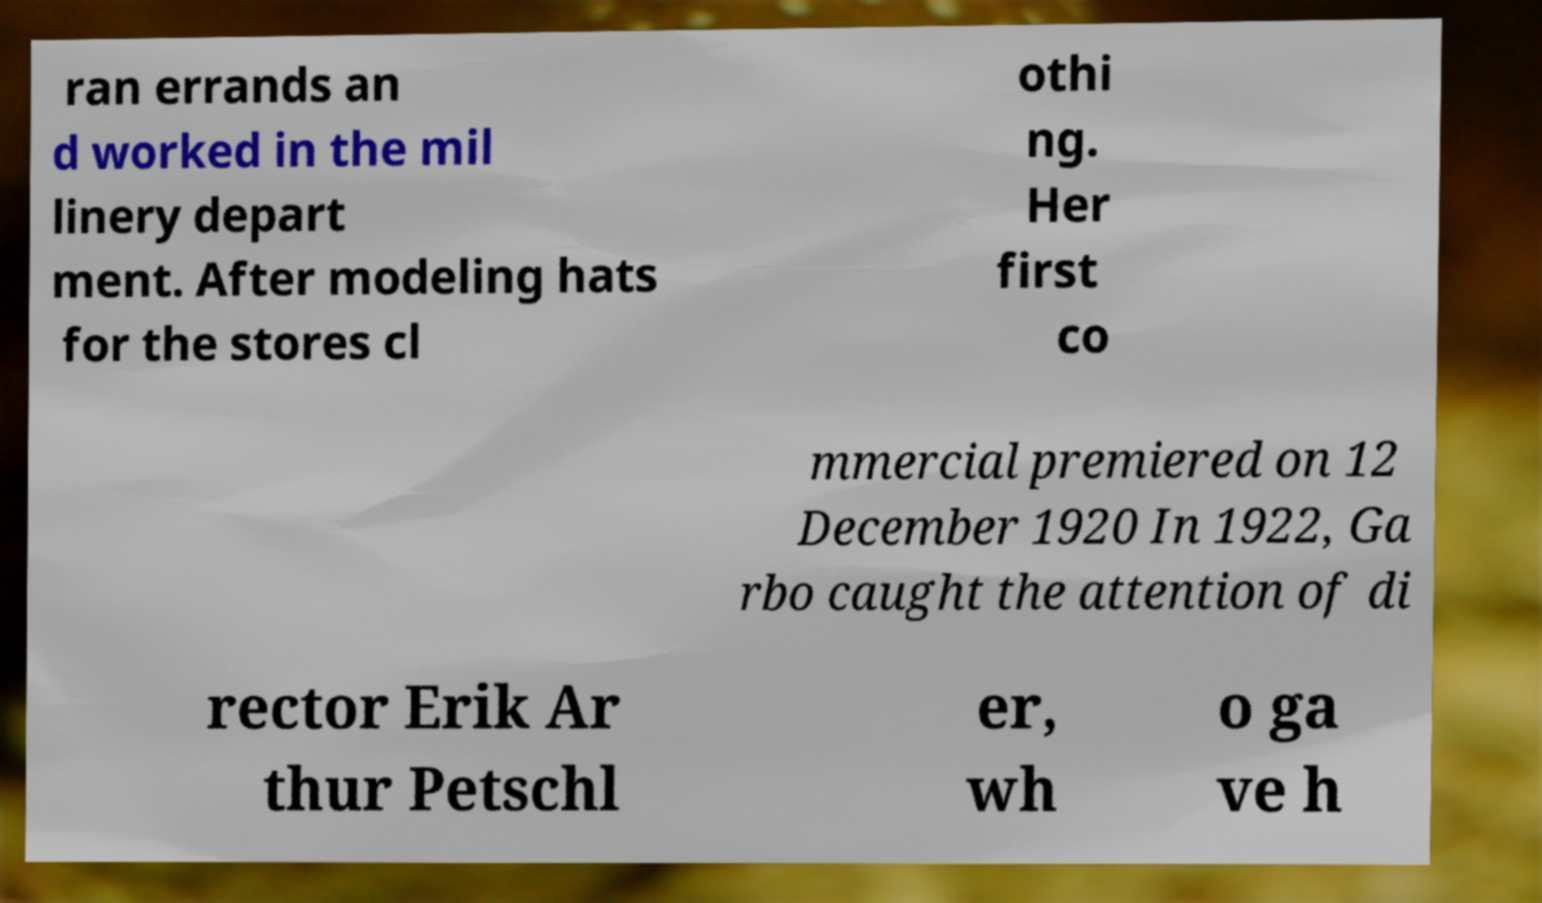There's text embedded in this image that I need extracted. Can you transcribe it verbatim? ran errands an d worked in the mil linery depart ment. After modeling hats for the stores cl othi ng. Her first co mmercial premiered on 12 December 1920 In 1922, Ga rbo caught the attention of di rector Erik Ar thur Petschl er, wh o ga ve h 